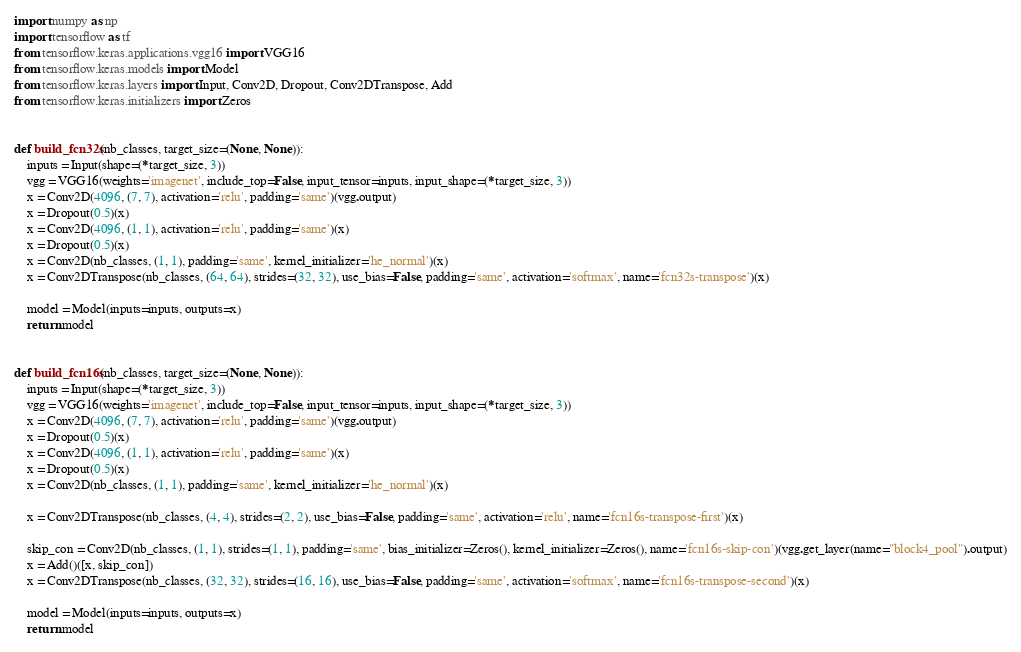Convert code to text. <code><loc_0><loc_0><loc_500><loc_500><_Python_>import numpy as np
import tensorflow as tf
from tensorflow.keras.applications.vgg16 import VGG16
from tensorflow.keras.models import Model
from tensorflow.keras.layers import Input, Conv2D, Dropout, Conv2DTranspose, Add
from tensorflow.keras.initializers import Zeros


def build_fcn32s(nb_classes, target_size=(None, None)):
    inputs = Input(shape=(*target_size, 3))
    vgg = VGG16(weights='imagenet', include_top=False, input_tensor=inputs, input_shape=(*target_size, 3))
    x = Conv2D(4096, (7, 7), activation='relu', padding='same')(vgg.output)
    x = Dropout(0.5)(x)
    x = Conv2D(4096, (1, 1), activation='relu', padding='same')(x)
    x = Dropout(0.5)(x)
    x = Conv2D(nb_classes, (1, 1), padding='same', kernel_initializer='he_normal')(x)
    x = Conv2DTranspose(nb_classes, (64, 64), strides=(32, 32), use_bias=False, padding='same', activation='softmax', name='fcn32s-transpose')(x)

    model = Model(inputs=inputs, outputs=x)
    return model


def build_fcn16s(nb_classes, target_size=(None, None)):
    inputs = Input(shape=(*target_size, 3))
    vgg = VGG16(weights='imagenet', include_top=False, input_tensor=inputs, input_shape=(*target_size, 3))
    x = Conv2D(4096, (7, 7), activation='relu', padding='same')(vgg.output)
    x = Dropout(0.5)(x)
    x = Conv2D(4096, (1, 1), activation='relu', padding='same')(x)
    x = Dropout(0.5)(x)
    x = Conv2D(nb_classes, (1, 1), padding='same', kernel_initializer='he_normal')(x)

    x = Conv2DTranspose(nb_classes, (4, 4), strides=(2, 2), use_bias=False, padding='same', activation='relu', name='fcn16s-transpose-first')(x)

    skip_con = Conv2D(nb_classes, (1, 1), strides=(1, 1), padding='same', bias_initializer=Zeros(), kernel_initializer=Zeros(), name='fcn16s-skip-con')(vgg.get_layer(name="block4_pool").output)
    x = Add()([x, skip_con])
    x = Conv2DTranspose(nb_classes, (32, 32), strides=(16, 16), use_bias=False, padding='same', activation='softmax', name='fcn16s-transpose-second')(x)

    model = Model(inputs=inputs, outputs=x)
    return model

</code> 